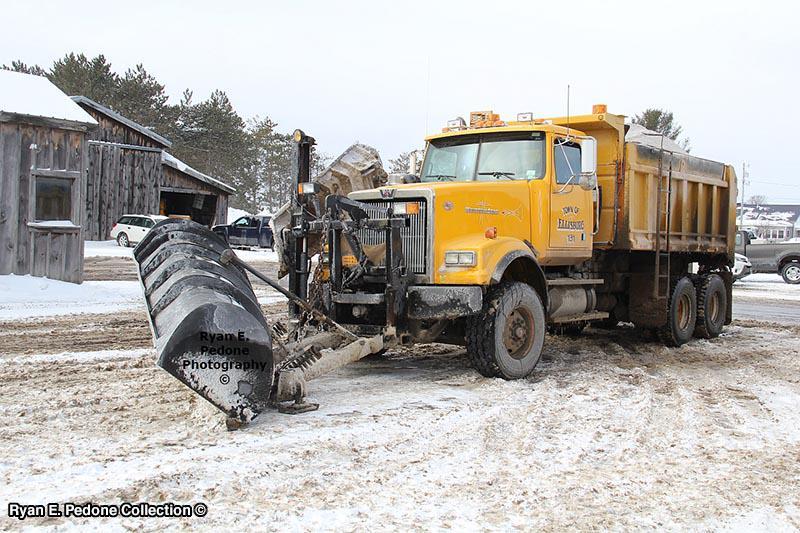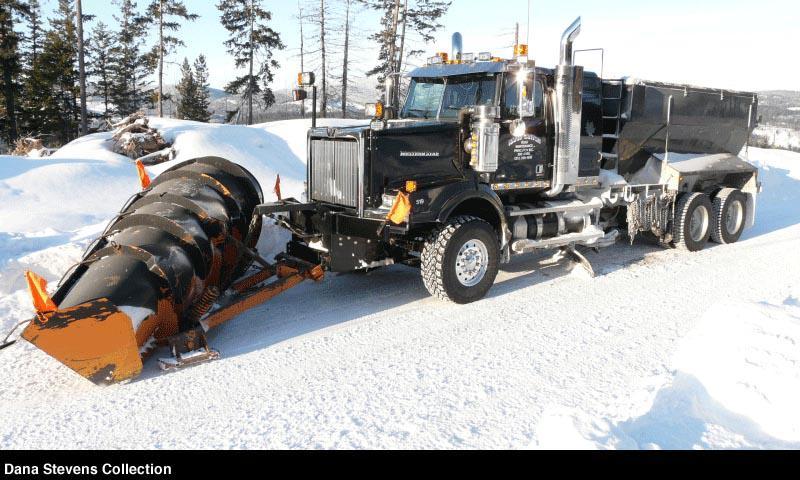The first image is the image on the left, the second image is the image on the right. Evaluate the accuracy of this statement regarding the images: "The truck is passing a building in one of the iamges.". Is it true? Answer yes or no. Yes. 